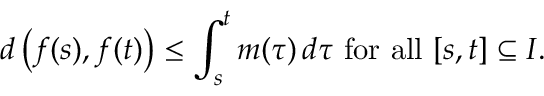<formula> <loc_0><loc_0><loc_500><loc_500>d \left ( f ( s ) , f ( t ) \right ) \leq \int _ { s } ^ { t } m ( \tau ) \, d \tau { f o r a l l } [ s , t ] \subseteq I .</formula> 